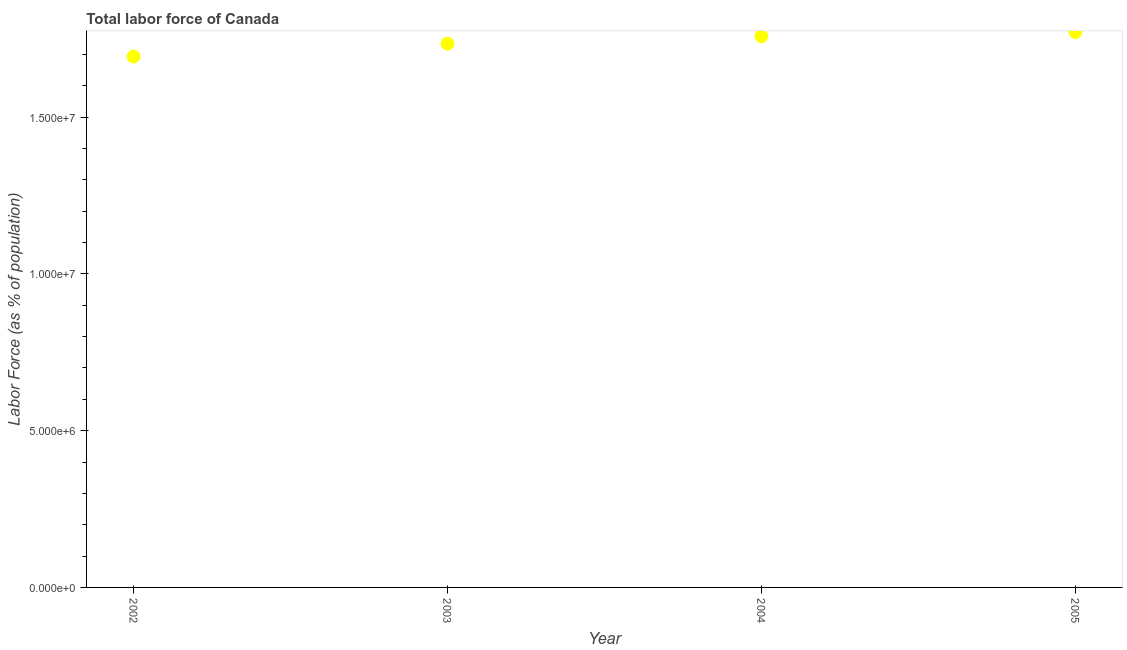What is the total labor force in 2005?
Your response must be concise. 1.77e+07. Across all years, what is the maximum total labor force?
Your response must be concise. 1.77e+07. Across all years, what is the minimum total labor force?
Offer a very short reply. 1.69e+07. In which year was the total labor force minimum?
Offer a terse response. 2002. What is the sum of the total labor force?
Your answer should be compact. 6.96e+07. What is the difference between the total labor force in 2002 and 2004?
Keep it short and to the point. -6.46e+05. What is the average total labor force per year?
Make the answer very short. 1.74e+07. What is the median total labor force?
Your answer should be very brief. 1.75e+07. What is the ratio of the total labor force in 2002 to that in 2004?
Give a very brief answer. 0.96. Is the total labor force in 2002 less than that in 2005?
Offer a very short reply. Yes. What is the difference between the highest and the second highest total labor force?
Ensure brevity in your answer.  1.34e+05. Is the sum of the total labor force in 2004 and 2005 greater than the maximum total labor force across all years?
Your answer should be compact. Yes. What is the difference between the highest and the lowest total labor force?
Offer a terse response. 7.80e+05. In how many years, is the total labor force greater than the average total labor force taken over all years?
Keep it short and to the point. 2. How many dotlines are there?
Provide a succinct answer. 1. How many years are there in the graph?
Offer a very short reply. 4. What is the difference between two consecutive major ticks on the Y-axis?
Your response must be concise. 5.00e+06. Does the graph contain grids?
Ensure brevity in your answer.  No. What is the title of the graph?
Ensure brevity in your answer.  Total labor force of Canada. What is the label or title of the X-axis?
Make the answer very short. Year. What is the label or title of the Y-axis?
Provide a short and direct response. Labor Force (as % of population). What is the Labor Force (as % of population) in 2002?
Offer a terse response. 1.69e+07. What is the Labor Force (as % of population) in 2003?
Your answer should be compact. 1.73e+07. What is the Labor Force (as % of population) in 2004?
Ensure brevity in your answer.  1.76e+07. What is the Labor Force (as % of population) in 2005?
Offer a terse response. 1.77e+07. What is the difference between the Labor Force (as % of population) in 2002 and 2003?
Provide a succinct answer. -4.09e+05. What is the difference between the Labor Force (as % of population) in 2002 and 2004?
Make the answer very short. -6.46e+05. What is the difference between the Labor Force (as % of population) in 2002 and 2005?
Your answer should be compact. -7.80e+05. What is the difference between the Labor Force (as % of population) in 2003 and 2004?
Offer a very short reply. -2.37e+05. What is the difference between the Labor Force (as % of population) in 2003 and 2005?
Ensure brevity in your answer.  -3.71e+05. What is the difference between the Labor Force (as % of population) in 2004 and 2005?
Your answer should be very brief. -1.34e+05. What is the ratio of the Labor Force (as % of population) in 2002 to that in 2004?
Your answer should be compact. 0.96. What is the ratio of the Labor Force (as % of population) in 2002 to that in 2005?
Give a very brief answer. 0.96. What is the ratio of the Labor Force (as % of population) in 2003 to that in 2004?
Provide a succinct answer. 0.99. What is the ratio of the Labor Force (as % of population) in 2003 to that in 2005?
Keep it short and to the point. 0.98. What is the ratio of the Labor Force (as % of population) in 2004 to that in 2005?
Keep it short and to the point. 0.99. 